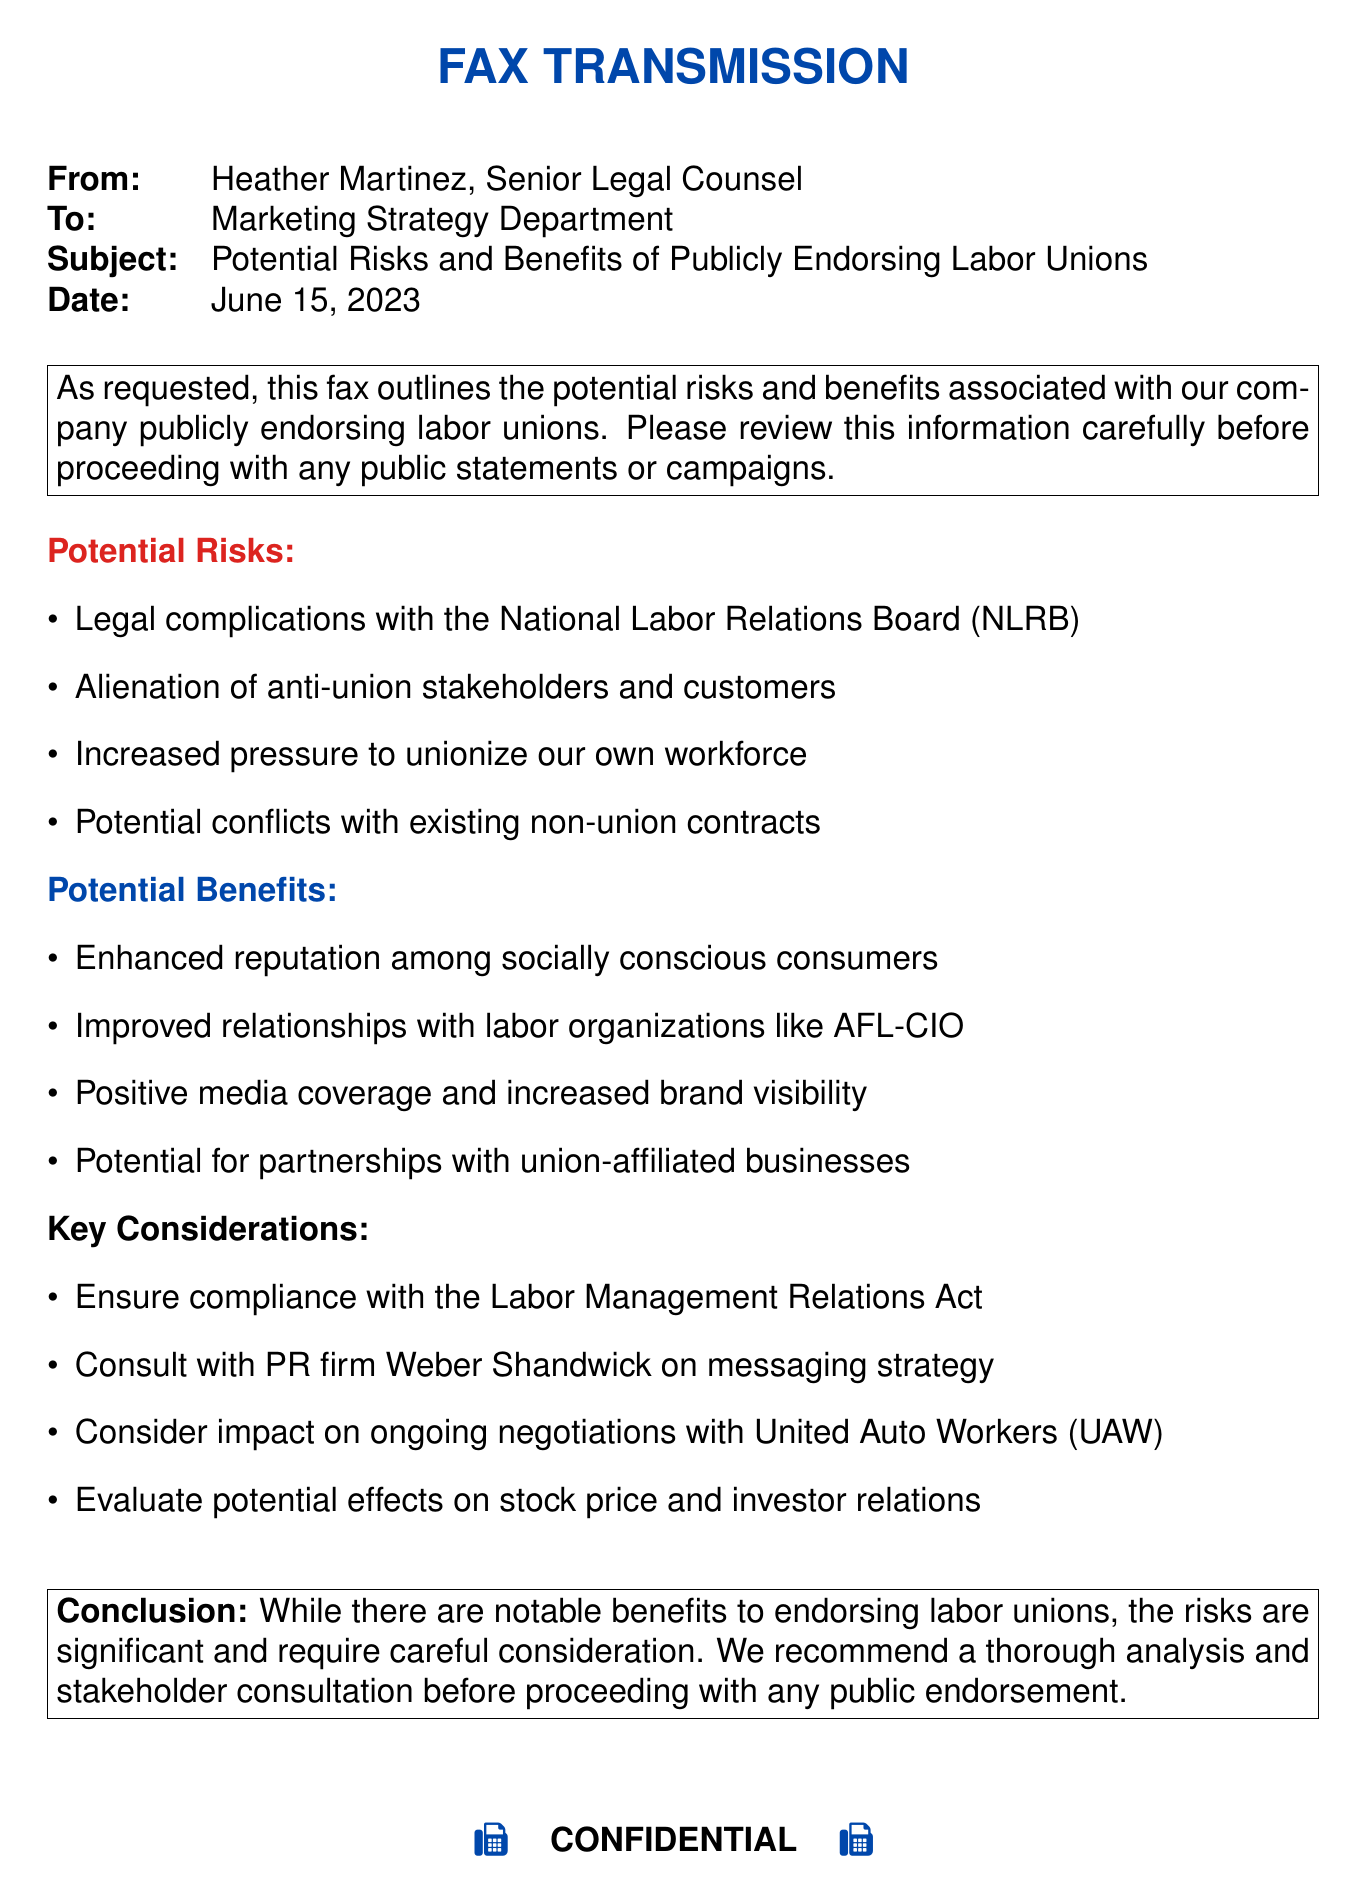what is the date of the fax? The date of the fax is stated clearly in the document as June 15, 2023.
Answer: June 15, 2023 who is the sender of the fax? The sender's name and title are provided in the fax, which is Heather Martinez, Senior Legal Counsel.
Answer: Heather Martinez, Senior Legal Counsel what is one potential risk mentioned in the document? The document lists several potential risks under a specific section; one of them is "Legal complications with the National Labor Relations Board (NLRB)."
Answer: Legal complications with the National Labor Relations Board (NLRB) name one potential benefit of endorsing labor unions. The document outlines various potential benefits, one of which is "Enhanced reputation among socially conscious consumers."
Answer: Enhanced reputation among socially conscious consumers what should be consulted regarding messaging strategy? The document suggests consulting a specific PR firm for clarity on messaging strategy, which is Weber Shandwick.
Answer: Weber Shandwick how many potential risks are listed in the fax? The document provides a complete enumeration of potential risks, totaling four mentioned items.
Answer: Four what is a key consideration mentioned in the document? A specific item noted in the document under key considerations includes "Ensure compliance with the Labor Management Relations Act."
Answer: Ensure compliance with the Labor Management Relations Act what type of document is this? The document is formatted and designated as a transmission from a legal department, labeled as a fax.
Answer: Fax 